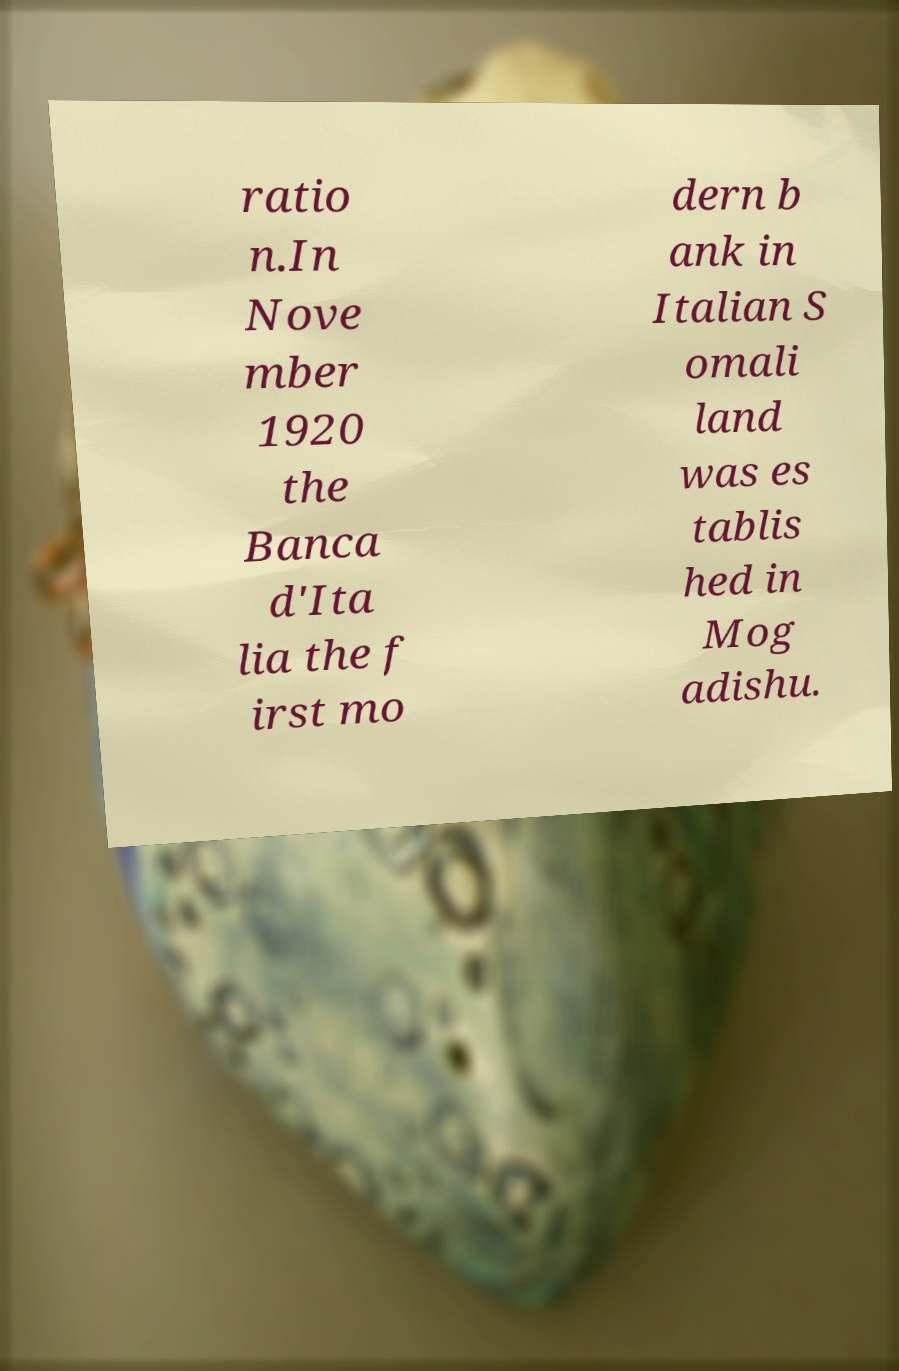Please identify and transcribe the text found in this image. ratio n.In Nove mber 1920 the Banca d'Ita lia the f irst mo dern b ank in Italian S omali land was es tablis hed in Mog adishu. 